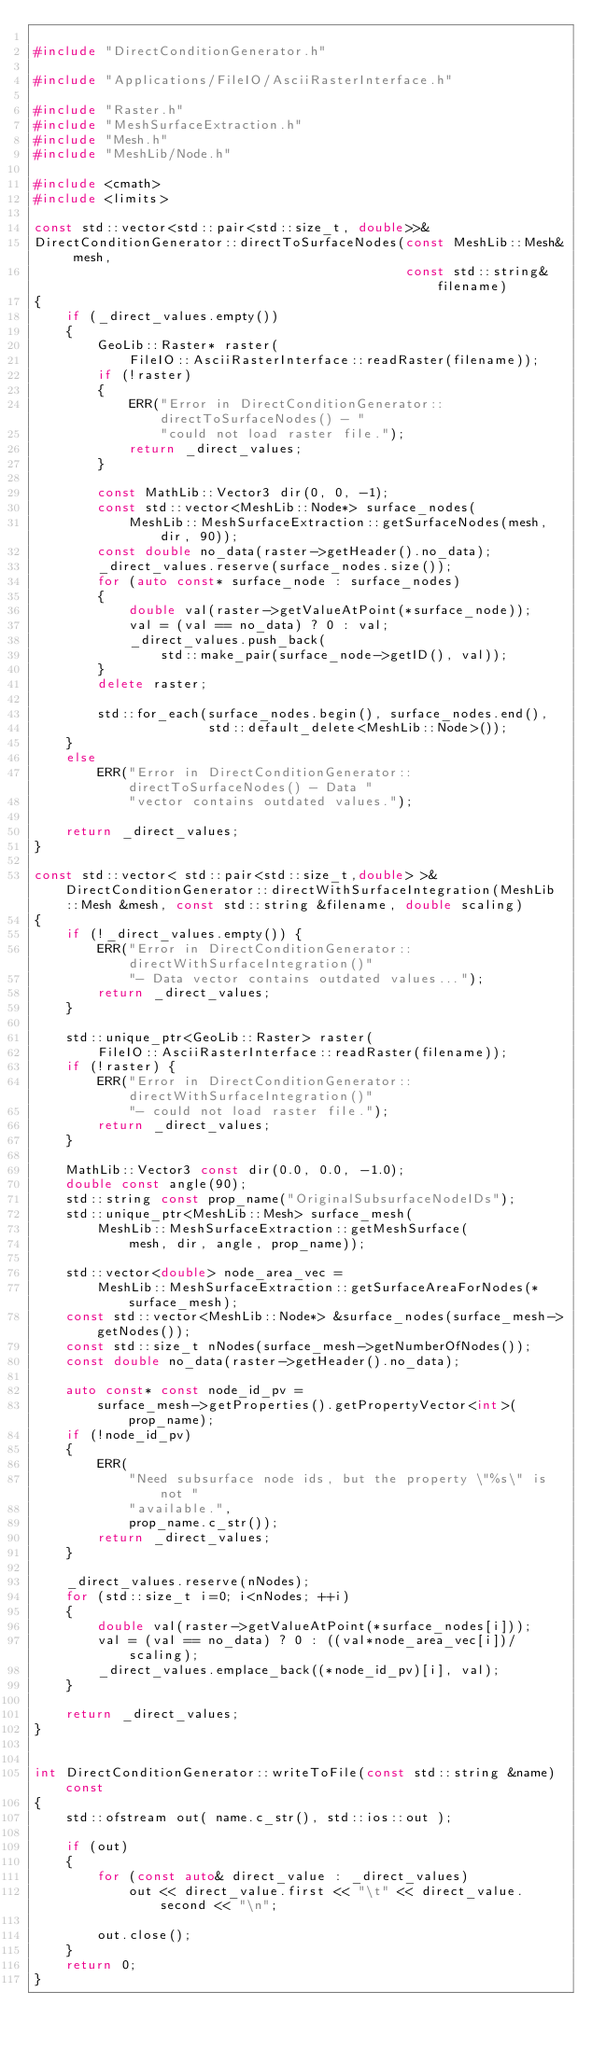Convert code to text. <code><loc_0><loc_0><loc_500><loc_500><_C++_>
#include "DirectConditionGenerator.h"

#include "Applications/FileIO/AsciiRasterInterface.h"

#include "Raster.h"
#include "MeshSurfaceExtraction.h"
#include "Mesh.h"
#include "MeshLib/Node.h"

#include <cmath>
#include <limits>

const std::vector<std::pair<std::size_t, double>>&
DirectConditionGenerator::directToSurfaceNodes(const MeshLib::Mesh& mesh,
                                               const std::string& filename)
{
    if (_direct_values.empty())
    {
        GeoLib::Raster* raster(
            FileIO::AsciiRasterInterface::readRaster(filename));
        if (!raster)
        {
            ERR("Error in DirectConditionGenerator::directToSurfaceNodes() - "
                "could not load raster file.");
            return _direct_values;
        }

        const MathLib::Vector3 dir(0, 0, -1);
        const std::vector<MeshLib::Node*> surface_nodes(
            MeshLib::MeshSurfaceExtraction::getSurfaceNodes(mesh, dir, 90));
        const double no_data(raster->getHeader().no_data);
        _direct_values.reserve(surface_nodes.size());
        for (auto const* surface_node : surface_nodes)
        {
            double val(raster->getValueAtPoint(*surface_node));
            val = (val == no_data) ? 0 : val;
            _direct_values.push_back(
                std::make_pair(surface_node->getID(), val));
        }
        delete raster;

        std::for_each(surface_nodes.begin(), surface_nodes.end(),
                      std::default_delete<MeshLib::Node>());
    }
    else
        ERR("Error in DirectConditionGenerator::directToSurfaceNodes() - Data "
            "vector contains outdated values.");

    return _direct_values;
}

const std::vector< std::pair<std::size_t,double> >& DirectConditionGenerator::directWithSurfaceIntegration(MeshLib::Mesh &mesh, const std::string &filename, double scaling)
{
    if (!_direct_values.empty()) {
        ERR("Error in DirectConditionGenerator::directWithSurfaceIntegration()"
            "- Data vector contains outdated values...");
        return _direct_values;
    }

    std::unique_ptr<GeoLib::Raster> raster(
        FileIO::AsciiRasterInterface::readRaster(filename));
    if (!raster) {
        ERR("Error in DirectConditionGenerator::directWithSurfaceIntegration()"
            "- could not load raster file.");
        return _direct_values;
    }

    MathLib::Vector3 const dir(0.0, 0.0, -1.0);
    double const angle(90);
    std::string const prop_name("OriginalSubsurfaceNodeIDs");
    std::unique_ptr<MeshLib::Mesh> surface_mesh(
        MeshLib::MeshSurfaceExtraction::getMeshSurface(
            mesh, dir, angle, prop_name));

    std::vector<double> node_area_vec =
        MeshLib::MeshSurfaceExtraction::getSurfaceAreaForNodes(*surface_mesh);
    const std::vector<MeshLib::Node*> &surface_nodes(surface_mesh->getNodes());
    const std::size_t nNodes(surface_mesh->getNumberOfNodes());
    const double no_data(raster->getHeader().no_data);

    auto const* const node_id_pv =
        surface_mesh->getProperties().getPropertyVector<int>(prop_name);
    if (!node_id_pv)
    {
        ERR(
            "Need subsurface node ids, but the property \"%s\" is not "
            "available.",
            prop_name.c_str());
        return _direct_values;
    }

    _direct_values.reserve(nNodes);
    for (std::size_t i=0; i<nNodes; ++i)
    {
        double val(raster->getValueAtPoint(*surface_nodes[i]));
        val = (val == no_data) ? 0 : ((val*node_area_vec[i])/scaling);
        _direct_values.emplace_back((*node_id_pv)[i], val);
    }

    return _direct_values;
}


int DirectConditionGenerator::writeToFile(const std::string &name) const
{
    std::ofstream out( name.c_str(), std::ios::out );

    if (out)
    {
        for (const auto& direct_value : _direct_values)
            out << direct_value.first << "\t" << direct_value.second << "\n";

        out.close();
    }
    return 0;
}
</code> 